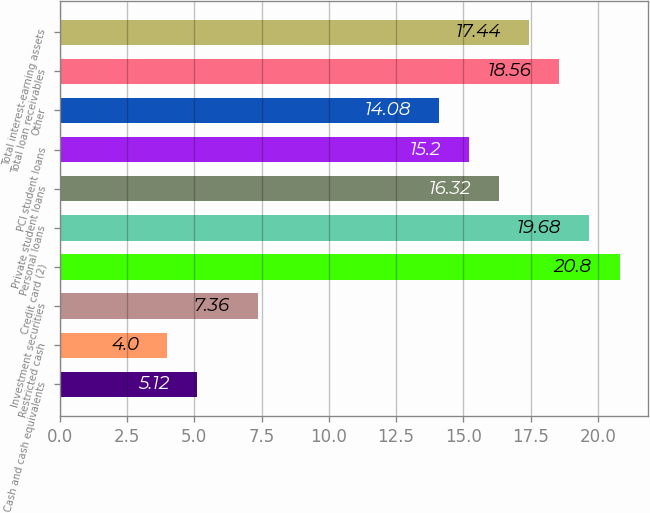<chart> <loc_0><loc_0><loc_500><loc_500><bar_chart><fcel>Cash and cash equivalents<fcel>Restricted cash<fcel>Investment securities<fcel>Credit card (2)<fcel>Personal loans<fcel>Private student loans<fcel>PCI student loans<fcel>Other<fcel>Total loan receivables<fcel>Total interest-earning assets<nl><fcel>5.12<fcel>4<fcel>7.36<fcel>20.8<fcel>19.68<fcel>16.32<fcel>15.2<fcel>14.08<fcel>18.56<fcel>17.44<nl></chart> 